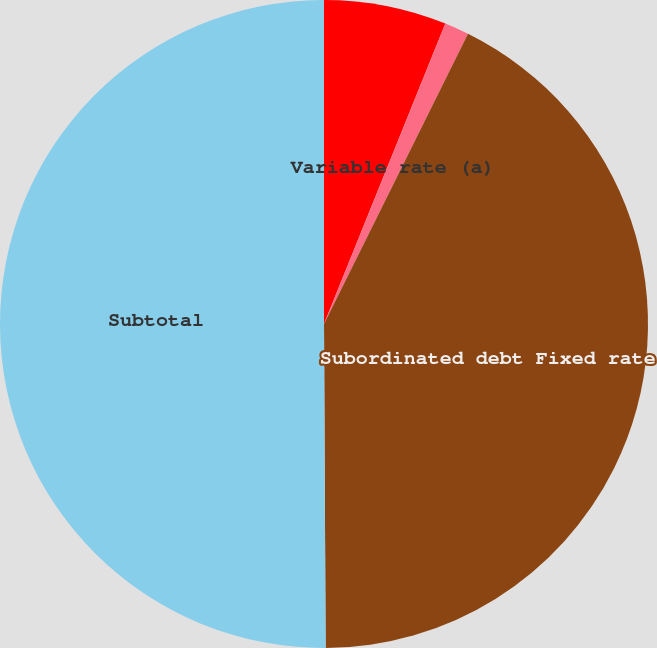<chart> <loc_0><loc_0><loc_500><loc_500><pie_chart><fcel>Senior debt Fixed rate<fcel>Variable rate (a)<fcel>Subordinated debt Fixed rate<fcel>Subtotal<nl><fcel>6.11%<fcel>1.22%<fcel>42.59%<fcel>50.08%<nl></chart> 